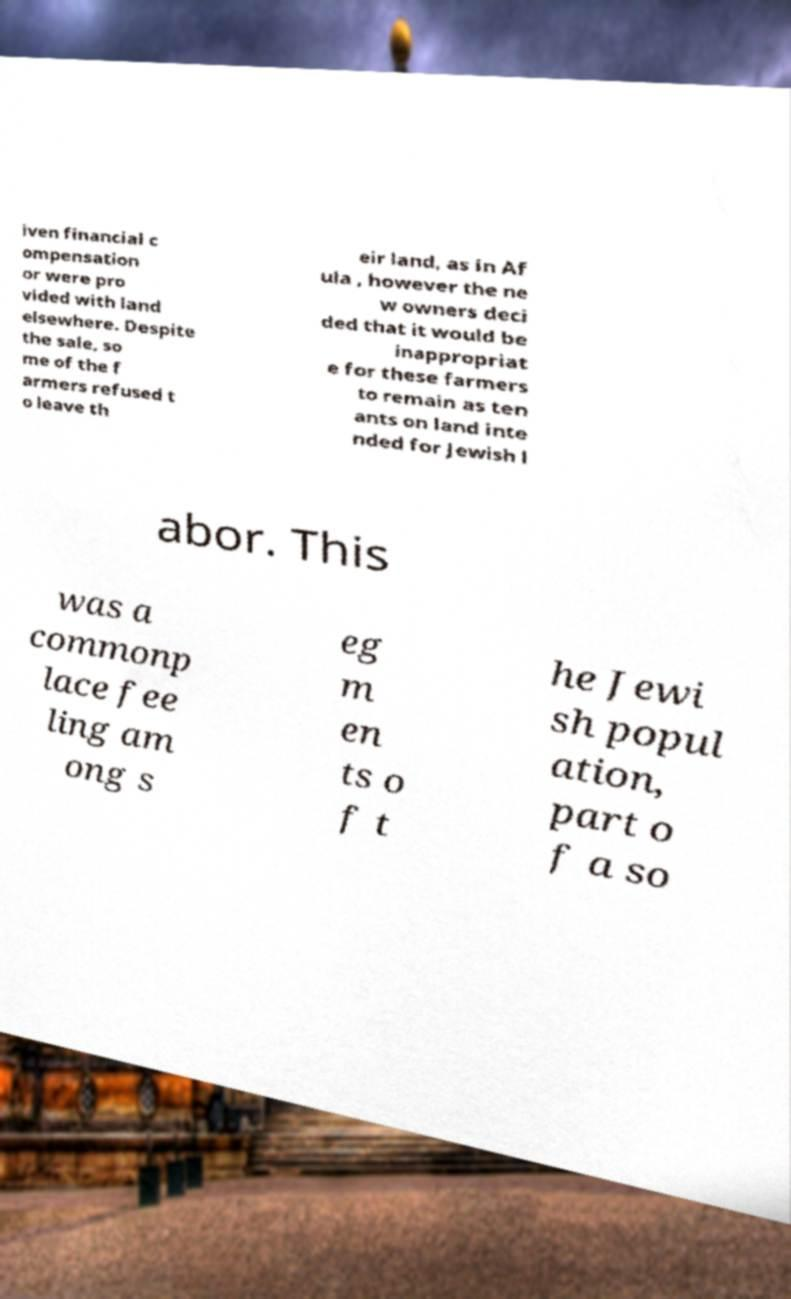Can you accurately transcribe the text from the provided image for me? iven financial c ompensation or were pro vided with land elsewhere. Despite the sale, so me of the f armers refused t o leave th eir land, as in Af ula , however the ne w owners deci ded that it would be inappropriat e for these farmers to remain as ten ants on land inte nded for Jewish l abor. This was a commonp lace fee ling am ong s eg m en ts o f t he Jewi sh popul ation, part o f a so 